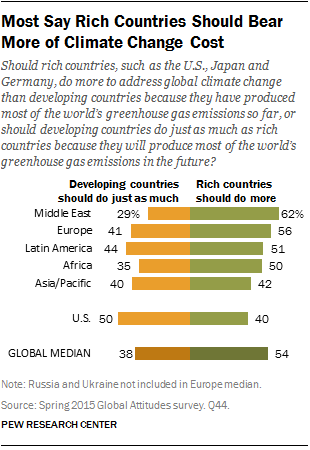Give some essential details in this illustration. The value of green bars in Africa is 50. The global median of the orange bar is not greater than the smallest value of the green bar. 